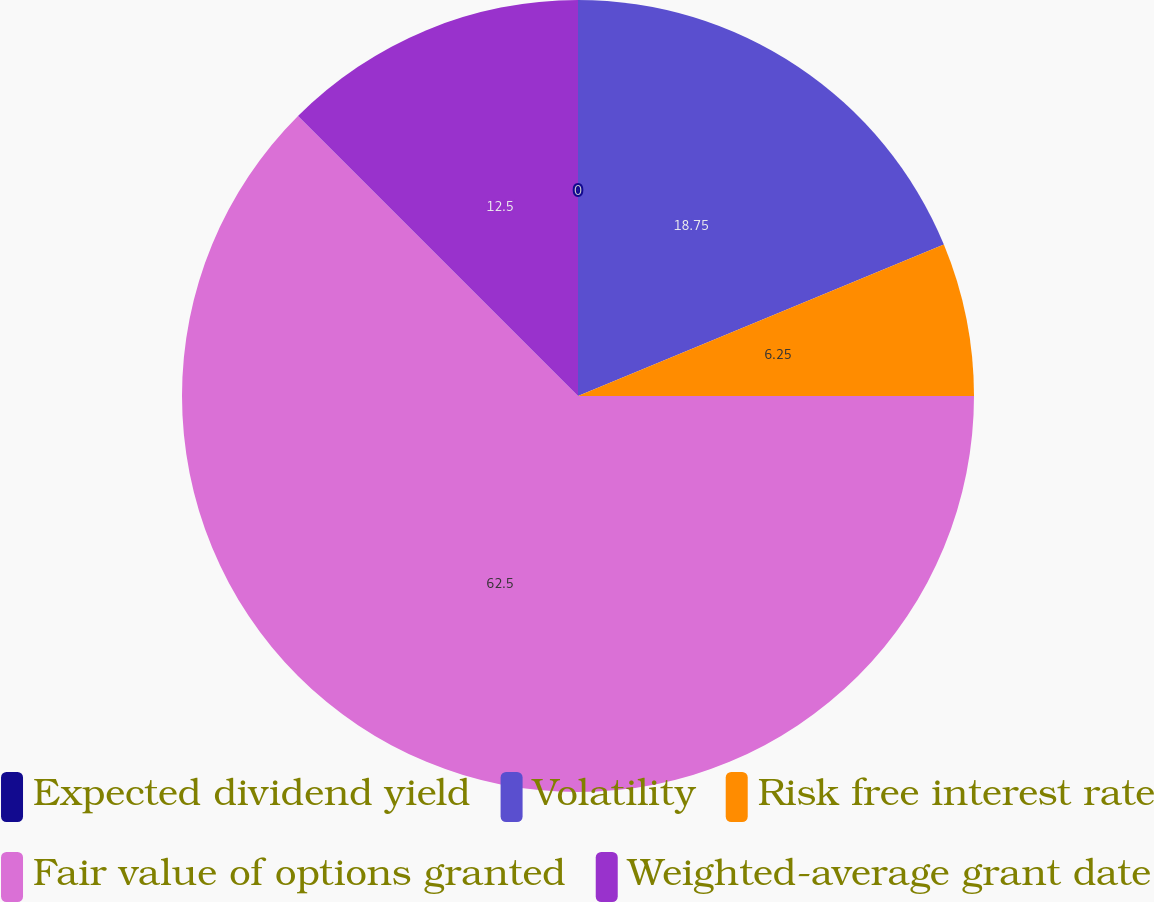<chart> <loc_0><loc_0><loc_500><loc_500><pie_chart><fcel>Expected dividend yield<fcel>Volatility<fcel>Risk free interest rate<fcel>Fair value of options granted<fcel>Weighted-average grant date<nl><fcel>0.0%<fcel>18.75%<fcel>6.25%<fcel>62.5%<fcel>12.5%<nl></chart> 